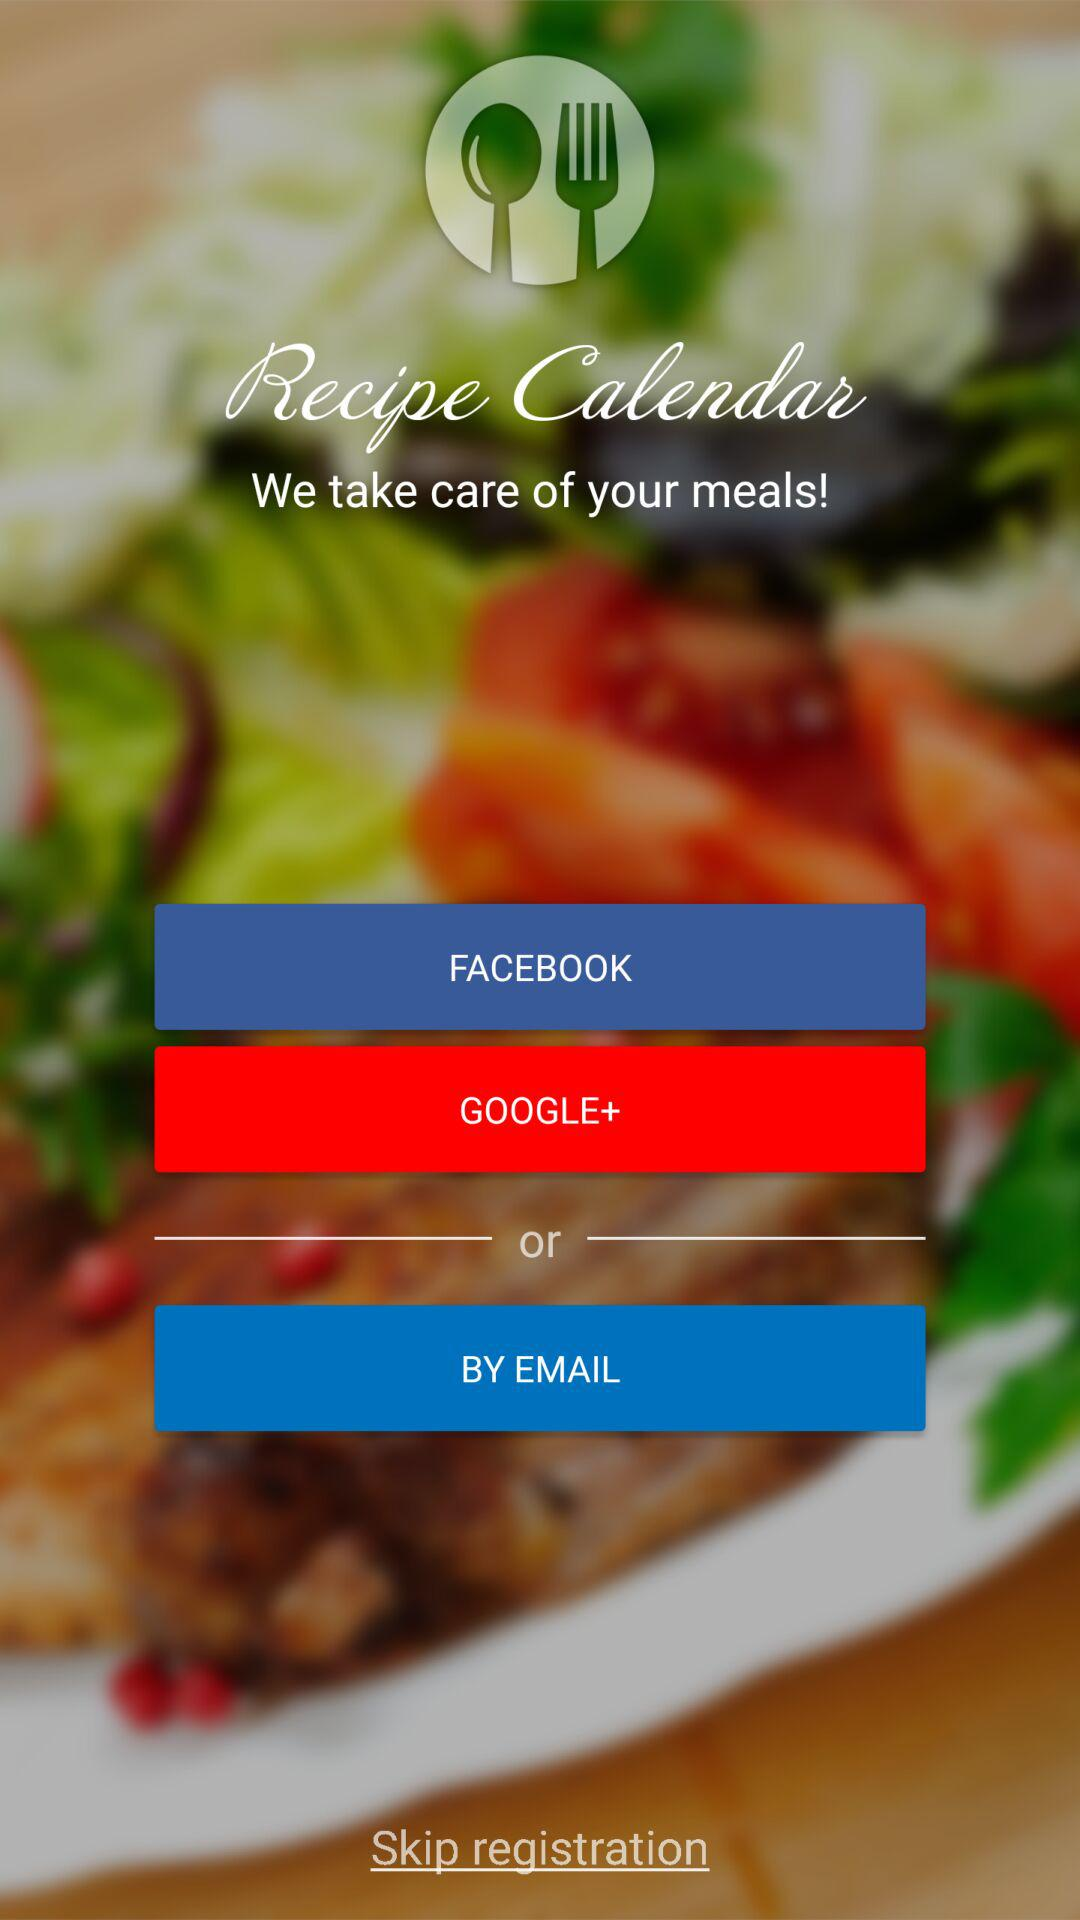What is the name of the application? The name of the application is "Recipe Calendar". 